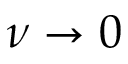<formula> <loc_0><loc_0><loc_500><loc_500>\nu \rightarrow 0</formula> 